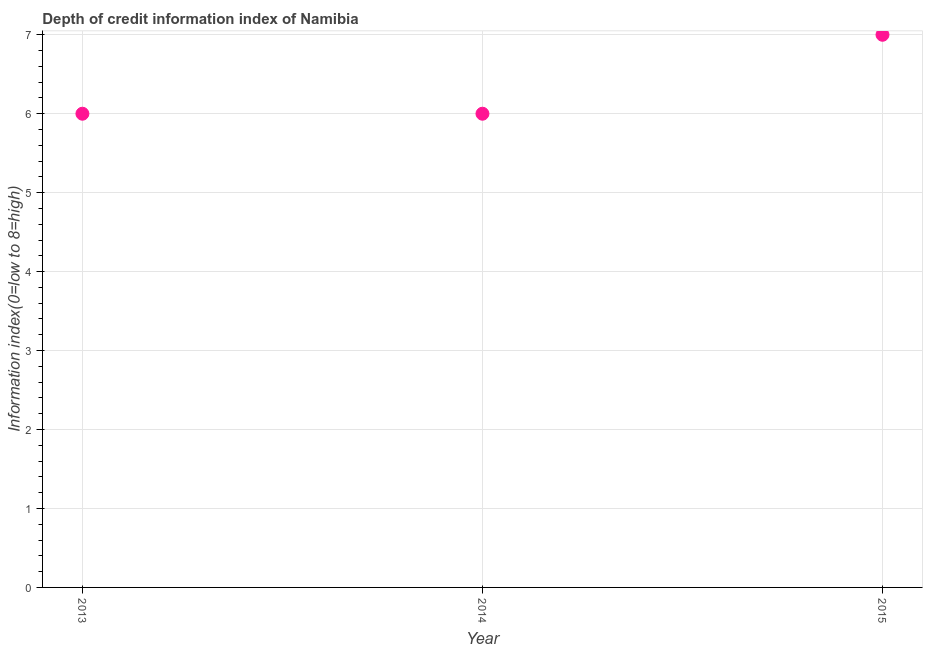What is the depth of credit information index in 2013?
Make the answer very short. 6. Across all years, what is the maximum depth of credit information index?
Keep it short and to the point. 7. In which year was the depth of credit information index maximum?
Make the answer very short. 2015. What is the sum of the depth of credit information index?
Make the answer very short. 19. What is the difference between the depth of credit information index in 2013 and 2015?
Your answer should be very brief. -1. What is the average depth of credit information index per year?
Give a very brief answer. 6.33. What is the median depth of credit information index?
Keep it short and to the point. 6. What is the difference between the highest and the lowest depth of credit information index?
Make the answer very short. 1. In how many years, is the depth of credit information index greater than the average depth of credit information index taken over all years?
Your response must be concise. 1. Are the values on the major ticks of Y-axis written in scientific E-notation?
Ensure brevity in your answer.  No. Does the graph contain any zero values?
Ensure brevity in your answer.  No. What is the title of the graph?
Ensure brevity in your answer.  Depth of credit information index of Namibia. What is the label or title of the Y-axis?
Make the answer very short. Information index(0=low to 8=high). What is the Information index(0=low to 8=high) in 2014?
Offer a very short reply. 6. What is the Information index(0=low to 8=high) in 2015?
Ensure brevity in your answer.  7. What is the ratio of the Information index(0=low to 8=high) in 2013 to that in 2015?
Provide a succinct answer. 0.86. What is the ratio of the Information index(0=low to 8=high) in 2014 to that in 2015?
Offer a terse response. 0.86. 